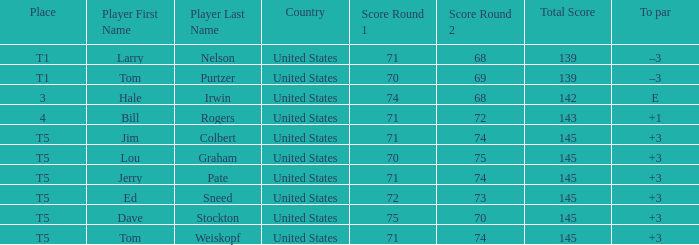What country is player ed sneed, who has a to par of +3, from? United States. 